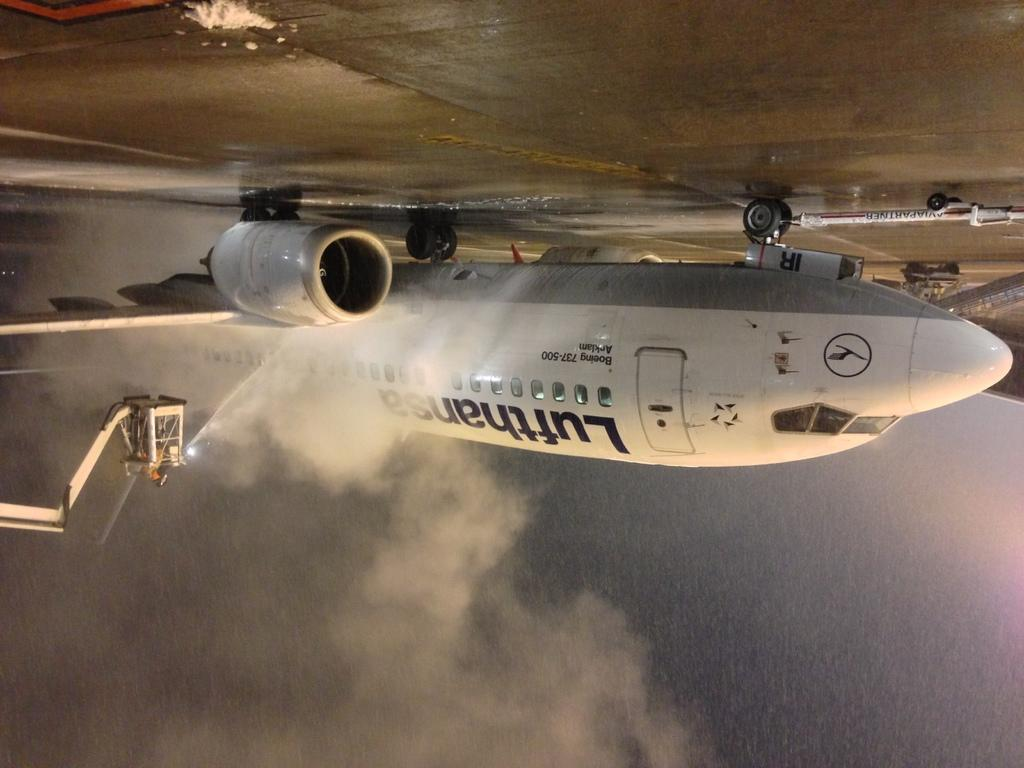<image>
Provide a brief description of the given image. A Lufthansa Boeing 737-500 Airplane sits in a run way. 